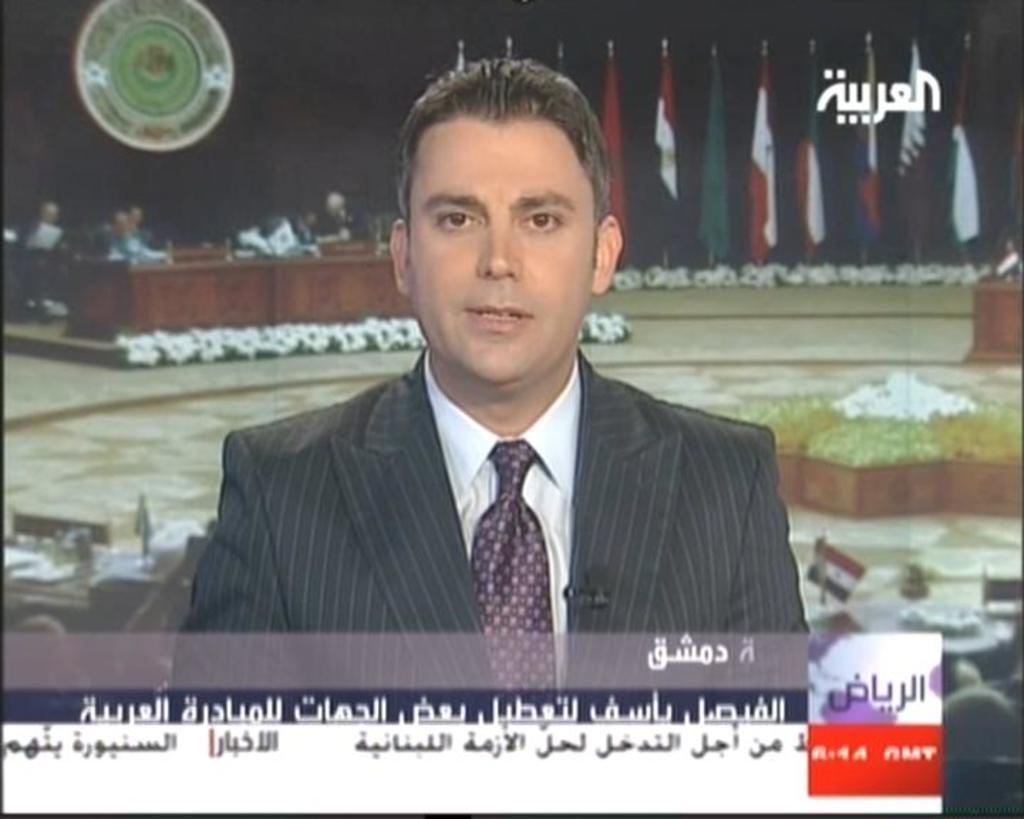What is the main object in the image? There is a screen in the image. What can be seen on the screen? A man is visible on the screen, along with text and people behind him. What else is present in the image besides the screen? There are flags visible in the image, as well as a table and objects. What type of dress is the person wearing in the image? There is no person present in the image; the main subject is a screen with a man visible on it. 